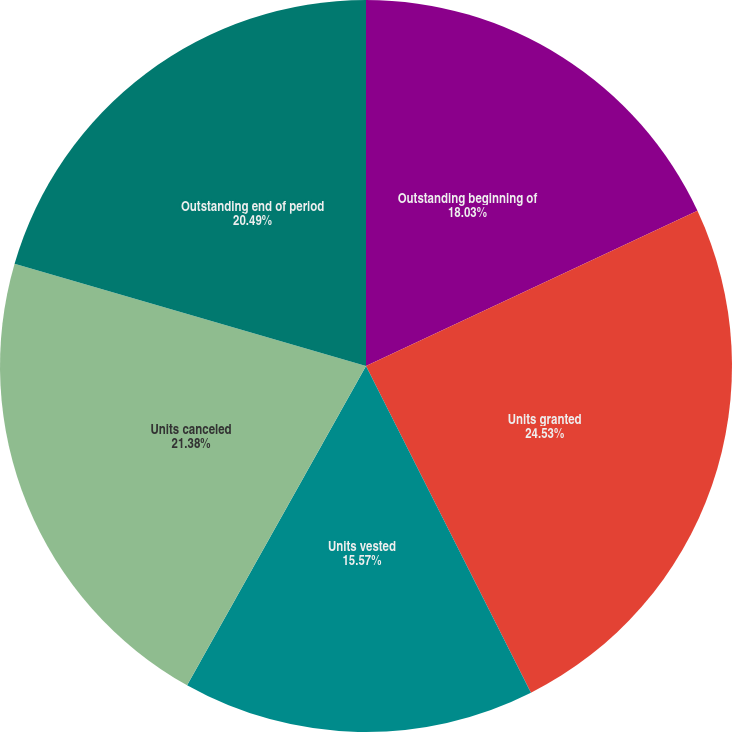Convert chart. <chart><loc_0><loc_0><loc_500><loc_500><pie_chart><fcel>Outstanding beginning of<fcel>Units granted<fcel>Units vested<fcel>Units canceled<fcel>Outstanding end of period<nl><fcel>18.03%<fcel>24.53%<fcel>15.57%<fcel>21.38%<fcel>20.49%<nl></chart> 